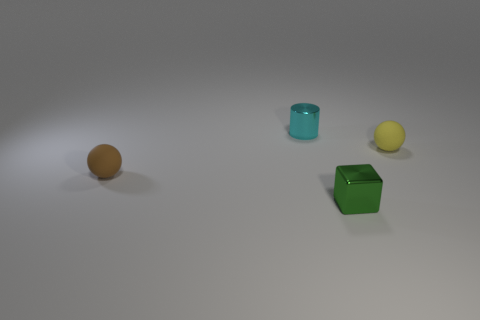What might the purpose of these objects be, and how could they be used? These objects could serve multiple purposes; they might be part of a child's educational toys designed to teach shapes and colors. Alternatively, they could be props for a photographer or a set designer, given the aesthetic spacing and clean background. Each object could be used to demonstrate the properties of geometric figures or to create visually appealing arrangements for artistic or illustrative purposes. 